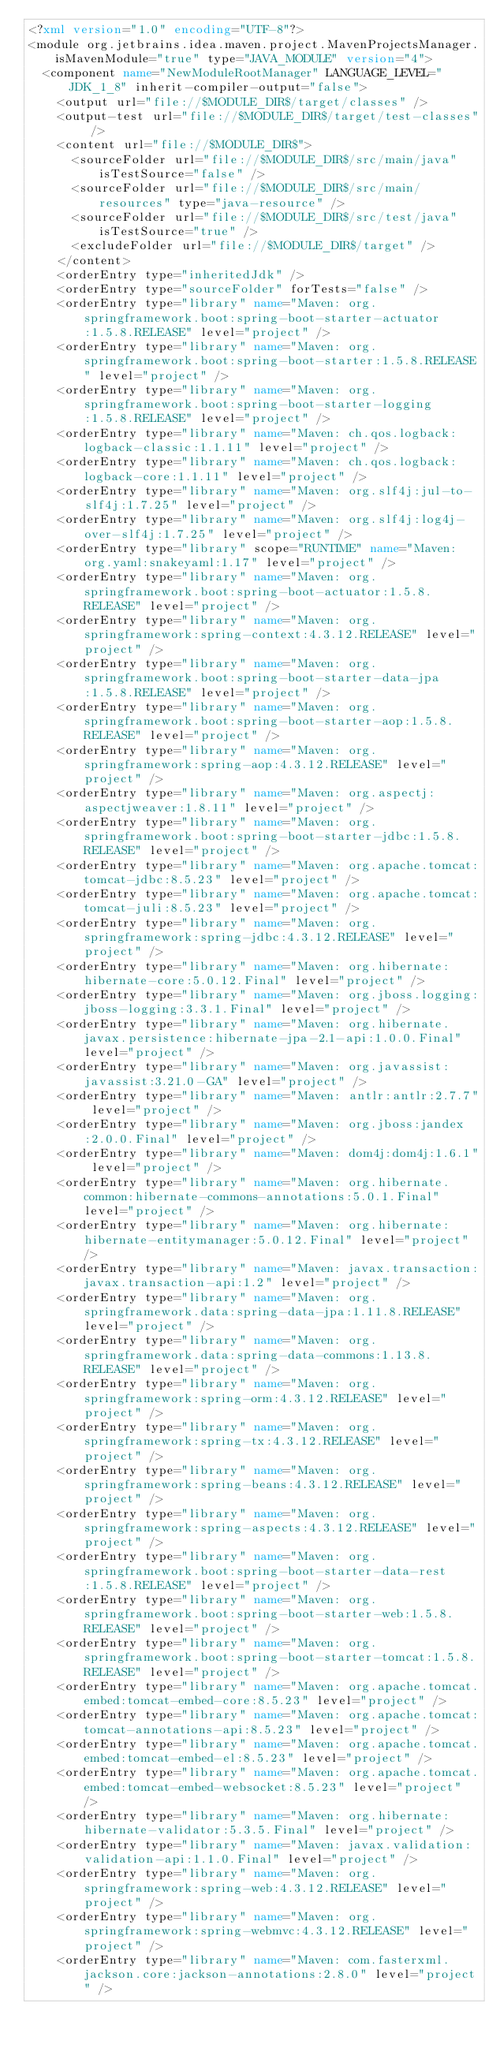Convert code to text. <code><loc_0><loc_0><loc_500><loc_500><_XML_><?xml version="1.0" encoding="UTF-8"?>
<module org.jetbrains.idea.maven.project.MavenProjectsManager.isMavenModule="true" type="JAVA_MODULE" version="4">
  <component name="NewModuleRootManager" LANGUAGE_LEVEL="JDK_1_8" inherit-compiler-output="false">
    <output url="file://$MODULE_DIR$/target/classes" />
    <output-test url="file://$MODULE_DIR$/target/test-classes" />
    <content url="file://$MODULE_DIR$">
      <sourceFolder url="file://$MODULE_DIR$/src/main/java" isTestSource="false" />
      <sourceFolder url="file://$MODULE_DIR$/src/main/resources" type="java-resource" />
      <sourceFolder url="file://$MODULE_DIR$/src/test/java" isTestSource="true" />
      <excludeFolder url="file://$MODULE_DIR$/target" />
    </content>
    <orderEntry type="inheritedJdk" />
    <orderEntry type="sourceFolder" forTests="false" />
    <orderEntry type="library" name="Maven: org.springframework.boot:spring-boot-starter-actuator:1.5.8.RELEASE" level="project" />
    <orderEntry type="library" name="Maven: org.springframework.boot:spring-boot-starter:1.5.8.RELEASE" level="project" />
    <orderEntry type="library" name="Maven: org.springframework.boot:spring-boot-starter-logging:1.5.8.RELEASE" level="project" />
    <orderEntry type="library" name="Maven: ch.qos.logback:logback-classic:1.1.11" level="project" />
    <orderEntry type="library" name="Maven: ch.qos.logback:logback-core:1.1.11" level="project" />
    <orderEntry type="library" name="Maven: org.slf4j:jul-to-slf4j:1.7.25" level="project" />
    <orderEntry type="library" name="Maven: org.slf4j:log4j-over-slf4j:1.7.25" level="project" />
    <orderEntry type="library" scope="RUNTIME" name="Maven: org.yaml:snakeyaml:1.17" level="project" />
    <orderEntry type="library" name="Maven: org.springframework.boot:spring-boot-actuator:1.5.8.RELEASE" level="project" />
    <orderEntry type="library" name="Maven: org.springframework:spring-context:4.3.12.RELEASE" level="project" />
    <orderEntry type="library" name="Maven: org.springframework.boot:spring-boot-starter-data-jpa:1.5.8.RELEASE" level="project" />
    <orderEntry type="library" name="Maven: org.springframework.boot:spring-boot-starter-aop:1.5.8.RELEASE" level="project" />
    <orderEntry type="library" name="Maven: org.springframework:spring-aop:4.3.12.RELEASE" level="project" />
    <orderEntry type="library" name="Maven: org.aspectj:aspectjweaver:1.8.11" level="project" />
    <orderEntry type="library" name="Maven: org.springframework.boot:spring-boot-starter-jdbc:1.5.8.RELEASE" level="project" />
    <orderEntry type="library" name="Maven: org.apache.tomcat:tomcat-jdbc:8.5.23" level="project" />
    <orderEntry type="library" name="Maven: org.apache.tomcat:tomcat-juli:8.5.23" level="project" />
    <orderEntry type="library" name="Maven: org.springframework:spring-jdbc:4.3.12.RELEASE" level="project" />
    <orderEntry type="library" name="Maven: org.hibernate:hibernate-core:5.0.12.Final" level="project" />
    <orderEntry type="library" name="Maven: org.jboss.logging:jboss-logging:3.3.1.Final" level="project" />
    <orderEntry type="library" name="Maven: org.hibernate.javax.persistence:hibernate-jpa-2.1-api:1.0.0.Final" level="project" />
    <orderEntry type="library" name="Maven: org.javassist:javassist:3.21.0-GA" level="project" />
    <orderEntry type="library" name="Maven: antlr:antlr:2.7.7" level="project" />
    <orderEntry type="library" name="Maven: org.jboss:jandex:2.0.0.Final" level="project" />
    <orderEntry type="library" name="Maven: dom4j:dom4j:1.6.1" level="project" />
    <orderEntry type="library" name="Maven: org.hibernate.common:hibernate-commons-annotations:5.0.1.Final" level="project" />
    <orderEntry type="library" name="Maven: org.hibernate:hibernate-entitymanager:5.0.12.Final" level="project" />
    <orderEntry type="library" name="Maven: javax.transaction:javax.transaction-api:1.2" level="project" />
    <orderEntry type="library" name="Maven: org.springframework.data:spring-data-jpa:1.11.8.RELEASE" level="project" />
    <orderEntry type="library" name="Maven: org.springframework.data:spring-data-commons:1.13.8.RELEASE" level="project" />
    <orderEntry type="library" name="Maven: org.springframework:spring-orm:4.3.12.RELEASE" level="project" />
    <orderEntry type="library" name="Maven: org.springframework:spring-tx:4.3.12.RELEASE" level="project" />
    <orderEntry type="library" name="Maven: org.springframework:spring-beans:4.3.12.RELEASE" level="project" />
    <orderEntry type="library" name="Maven: org.springframework:spring-aspects:4.3.12.RELEASE" level="project" />
    <orderEntry type="library" name="Maven: org.springframework.boot:spring-boot-starter-data-rest:1.5.8.RELEASE" level="project" />
    <orderEntry type="library" name="Maven: org.springframework.boot:spring-boot-starter-web:1.5.8.RELEASE" level="project" />
    <orderEntry type="library" name="Maven: org.springframework.boot:spring-boot-starter-tomcat:1.5.8.RELEASE" level="project" />
    <orderEntry type="library" name="Maven: org.apache.tomcat.embed:tomcat-embed-core:8.5.23" level="project" />
    <orderEntry type="library" name="Maven: org.apache.tomcat:tomcat-annotations-api:8.5.23" level="project" />
    <orderEntry type="library" name="Maven: org.apache.tomcat.embed:tomcat-embed-el:8.5.23" level="project" />
    <orderEntry type="library" name="Maven: org.apache.tomcat.embed:tomcat-embed-websocket:8.5.23" level="project" />
    <orderEntry type="library" name="Maven: org.hibernate:hibernate-validator:5.3.5.Final" level="project" />
    <orderEntry type="library" name="Maven: javax.validation:validation-api:1.1.0.Final" level="project" />
    <orderEntry type="library" name="Maven: org.springframework:spring-web:4.3.12.RELEASE" level="project" />
    <orderEntry type="library" name="Maven: org.springframework:spring-webmvc:4.3.12.RELEASE" level="project" />
    <orderEntry type="library" name="Maven: com.fasterxml.jackson.core:jackson-annotations:2.8.0" level="project" /></code> 